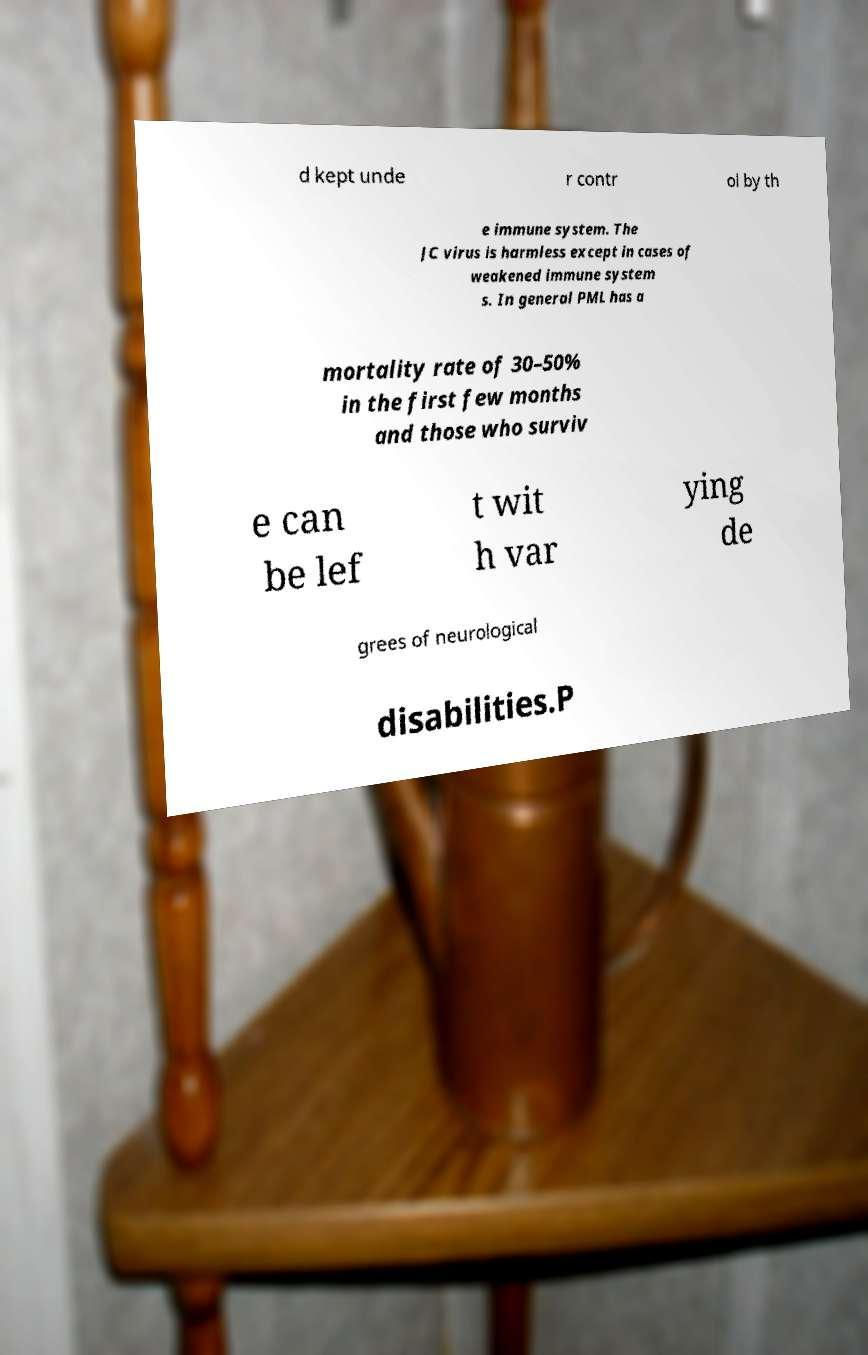Please identify and transcribe the text found in this image. d kept unde r contr ol by th e immune system. The JC virus is harmless except in cases of weakened immune system s. In general PML has a mortality rate of 30–50% in the first few months and those who surviv e can be lef t wit h var ying de grees of neurological disabilities.P 